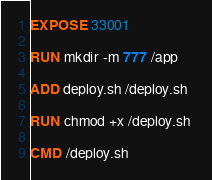Convert code to text. <code><loc_0><loc_0><loc_500><loc_500><_Dockerfile_>EXPOSE 33001

RUN mkdir -m 777 /app 

ADD deploy.sh /deploy.sh

RUN chmod +x /deploy.sh 

CMD /deploy.sh</code> 